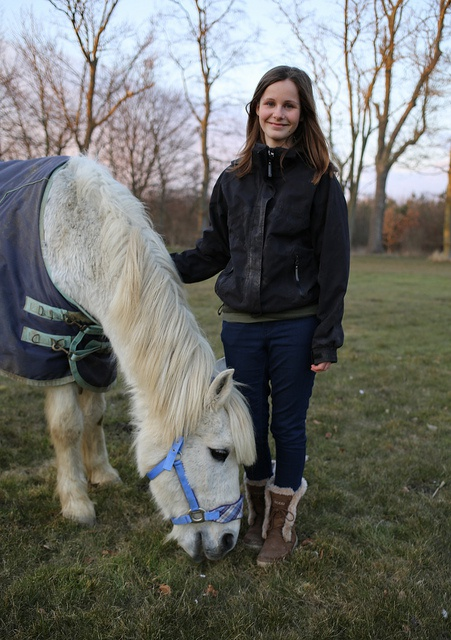Describe the objects in this image and their specific colors. I can see horse in lavender, darkgray, gray, and black tones and people in lavender, black, gray, and maroon tones in this image. 